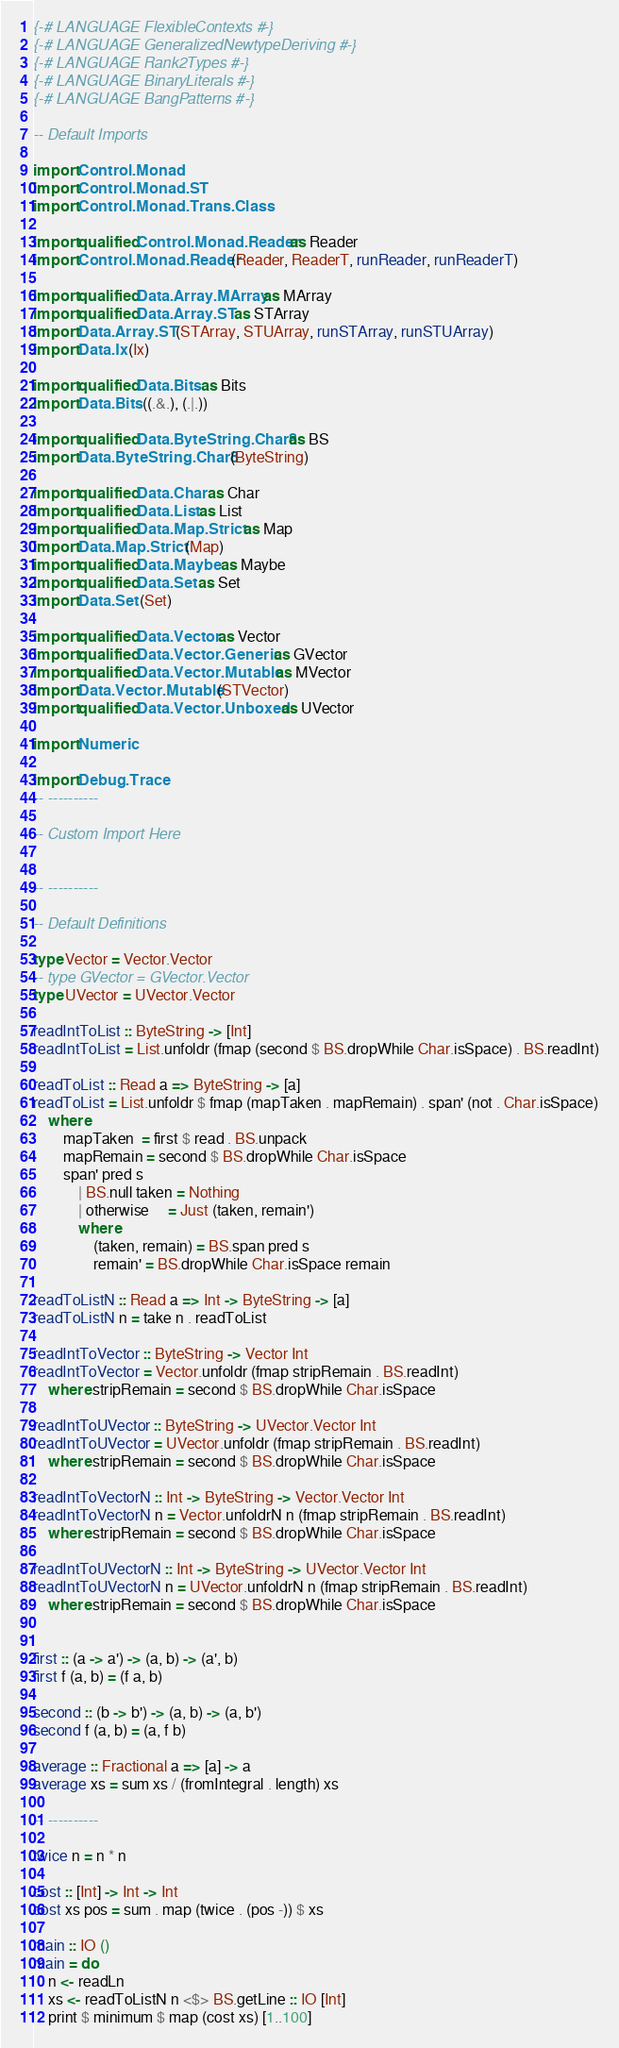<code> <loc_0><loc_0><loc_500><loc_500><_Haskell_>{-# LANGUAGE FlexibleContexts #-}
{-# LANGUAGE GeneralizedNewtypeDeriving #-}
{-# LANGUAGE Rank2Types #-}
{-# LANGUAGE BinaryLiterals #-}
{-# LANGUAGE BangPatterns #-}

-- Default Imports

import Control.Monad
import Control.Monad.ST
import Control.Monad.Trans.Class

import qualified Control.Monad.Reader as Reader
import Control.Monad.Reader (Reader, ReaderT, runReader, runReaderT)

import qualified Data.Array.MArray as MArray
import qualified Data.Array.ST as STArray
import Data.Array.ST (STArray, STUArray, runSTArray, runSTUArray)
import Data.Ix (Ix)

import qualified Data.Bits as Bits
import Data.Bits ((.&.), (.|.))

import qualified Data.ByteString.Char8 as BS
import Data.ByteString.Char8 (ByteString)

import qualified Data.Char as Char
import qualified Data.List as List
import qualified Data.Map.Strict as Map
import Data.Map.Strict (Map)
import qualified Data.Maybe as Maybe
import qualified Data.Set as Set
import Data.Set (Set)

import qualified Data.Vector as Vector
import qualified Data.Vector.Generic as GVector
import qualified Data.Vector.Mutable as MVector
import Data.Vector.Mutable (STVector)
import qualified Data.Vector.Unboxed as UVector

import Numeric

import Debug.Trace
-- ----------

-- Custom Import Here


-- ----------

-- Default Definitions

type Vector = Vector.Vector
-- type GVector = GVector.Vector
type UVector = UVector.Vector

readIntToList :: ByteString -> [Int]
readIntToList = List.unfoldr (fmap (second $ BS.dropWhile Char.isSpace) . BS.readInt)

readToList :: Read a => ByteString -> [a]
readToList = List.unfoldr $ fmap (mapTaken . mapRemain) . span' (not . Char.isSpace)
	where
		mapTaken  = first $ read . BS.unpack
		mapRemain = second $ BS.dropWhile Char.isSpace
		span' pred s
			| BS.null taken = Nothing
			| otherwise     = Just (taken, remain')
			where
				(taken, remain) = BS.span pred s
				remain' = BS.dropWhile Char.isSpace remain

readToListN :: Read a => Int -> ByteString -> [a]
readToListN n = take n . readToList

readIntToVector :: ByteString -> Vector Int
readIntToVector = Vector.unfoldr (fmap stripRemain . BS.readInt)
	where stripRemain = second $ BS.dropWhile Char.isSpace

readIntToUVector :: ByteString -> UVector.Vector Int
readIntToUVector = UVector.unfoldr (fmap stripRemain . BS.readInt)
	where stripRemain = second $ BS.dropWhile Char.isSpace

readIntToVectorN :: Int -> ByteString -> Vector.Vector Int
readIntToVectorN n = Vector.unfoldrN n (fmap stripRemain . BS.readInt)
	where stripRemain = second $ BS.dropWhile Char.isSpace

readIntToUVectorN :: Int -> ByteString -> UVector.Vector Int
readIntToUVectorN n = UVector.unfoldrN n (fmap stripRemain . BS.readInt)
	where stripRemain = second $ BS.dropWhile Char.isSpace


first :: (a -> a') -> (a, b) -> (a', b)
first f (a, b) = (f a, b)

second :: (b -> b') -> (a, b) -> (a, b')
second f (a, b) = (a, f b)

average :: Fractional a => [a] -> a
average xs = sum xs / (fromIntegral . length) xs

-- ----------

twice n = n * n

cost :: [Int] -> Int -> Int
cost xs pos = sum . map (twice . (pos -)) $ xs

main :: IO ()
main = do
	n <- readLn
	xs <- readToListN n <$> BS.getLine :: IO [Int]
	print $ minimum $ map (cost xs) [1..100]
</code> 